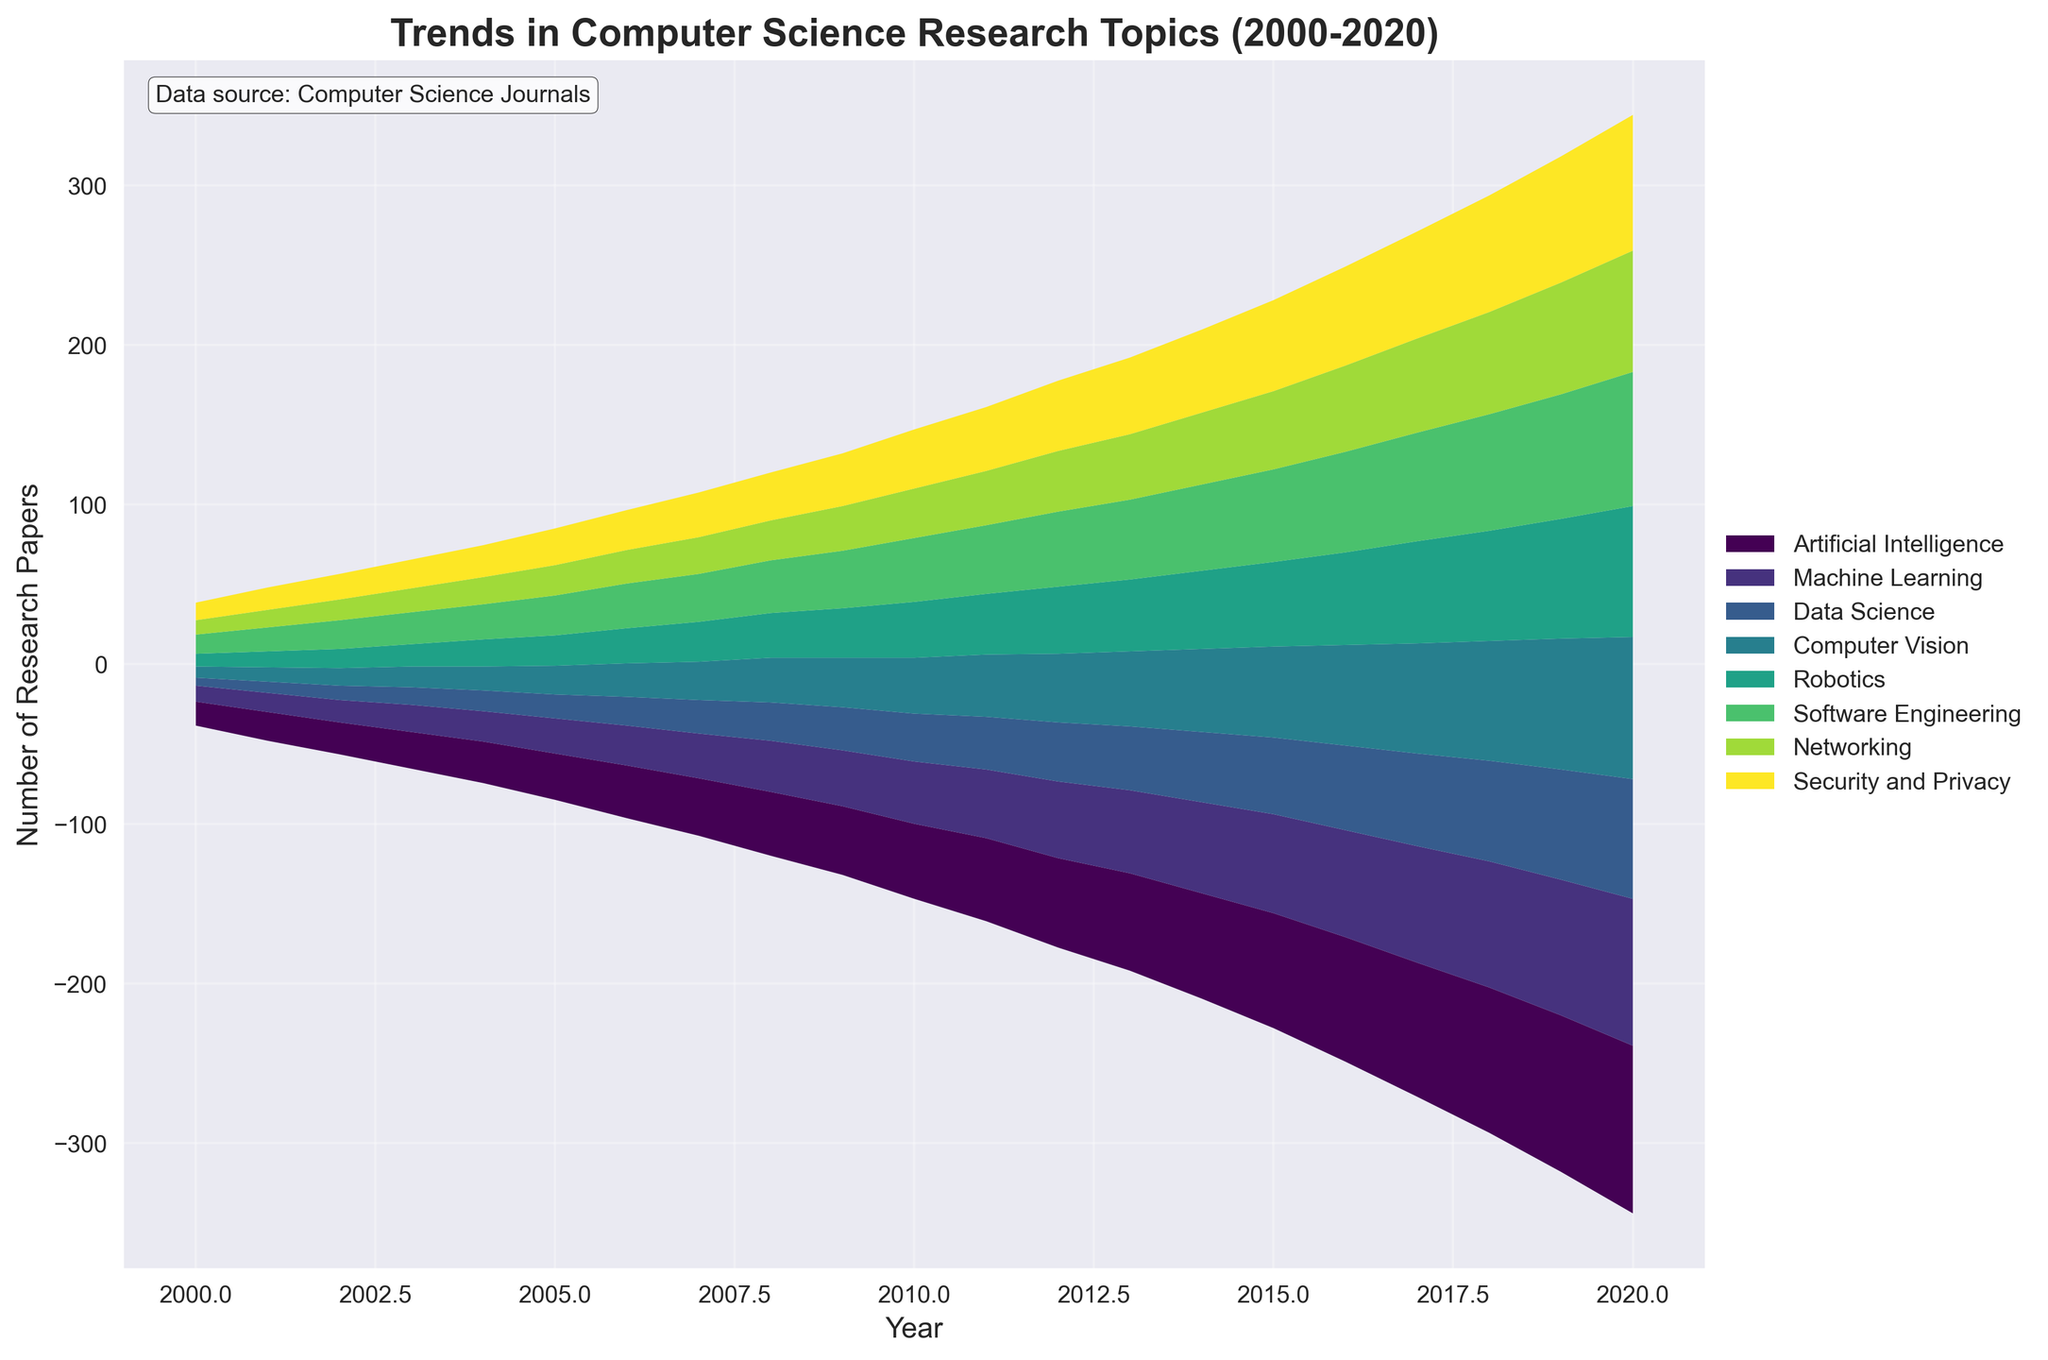What is the title of the plot? The title is typically displayed at the top of the figure. Here, the title is "Trends in Computer Science Research Topics (2000-2020)".
Answer: "Trends in Computer Science Research Topics (2000-2020)" Which research topic had the highest number of papers in 2020? To determine the topic with the highest number of papers in 2020, examine the uppermost layer of the stream graph at the year 2020, which typically represents the topic with the greatest volume.
Answer: Artificial Intelligence How many research topics are tracked in this plot? Count the number of different colored segments in the stack plot's legend; each segment represents a unique research topic.
Answer: 8 In which year did Data Science overtake Computer Vision in the number of research papers? To find when Data Science overtakes Computer Vision, observe the graph where the stream for Data Science becomes thicker than the stream for Computer Vision.
Answer: 2010 What were the two most popular research topics in 2010? To find the two most popular topics in 2010, look for the thickest two layers in the stream graph at the year 2010.
Answer: Artificial Intelligence, Machine Learning By how much did the number of Machine Learning papers increase from 2000 to 2020? Subtract the number of Machine Learning papers in 2000 from the number in 2020: 92 (2020) - 10 (2000).
Answer: 82 Which research topic had the least number of papers in 2005? To find the least popular topic in 2005, identify the thinnest layer in the stream graph at the year 2005.
Answer: Data Science Was the increase in research papers for Security and Privacy between 2015 and 2020 greater than for Networking? Calculate the difference in the number of papers for each topic between these years: Security and Privacy: 85 - 57, Networking: 76 - 49. Compare the results. Security and Privacy increase = 28, Networking increase = 27; Security and Privacy increased by one more paper.
Answer: Yes What is the general trend for research papers focused on Robotics from 2000 to 2020? Observe the shape of the Robotics layer over the timeline to note if it is generally increasing, decreasing, or remaining stable. The layer shows a general upward trend.
Answer: Increasing Which year marks the most significant rise in the number of research papers for Artificial Intelligence? Identify the year where the slope of the Artificial Intelligence layer is steepest, indicating the most considerable year-on-year increase. This appears most prominently around 2010.
Answer: 2010 